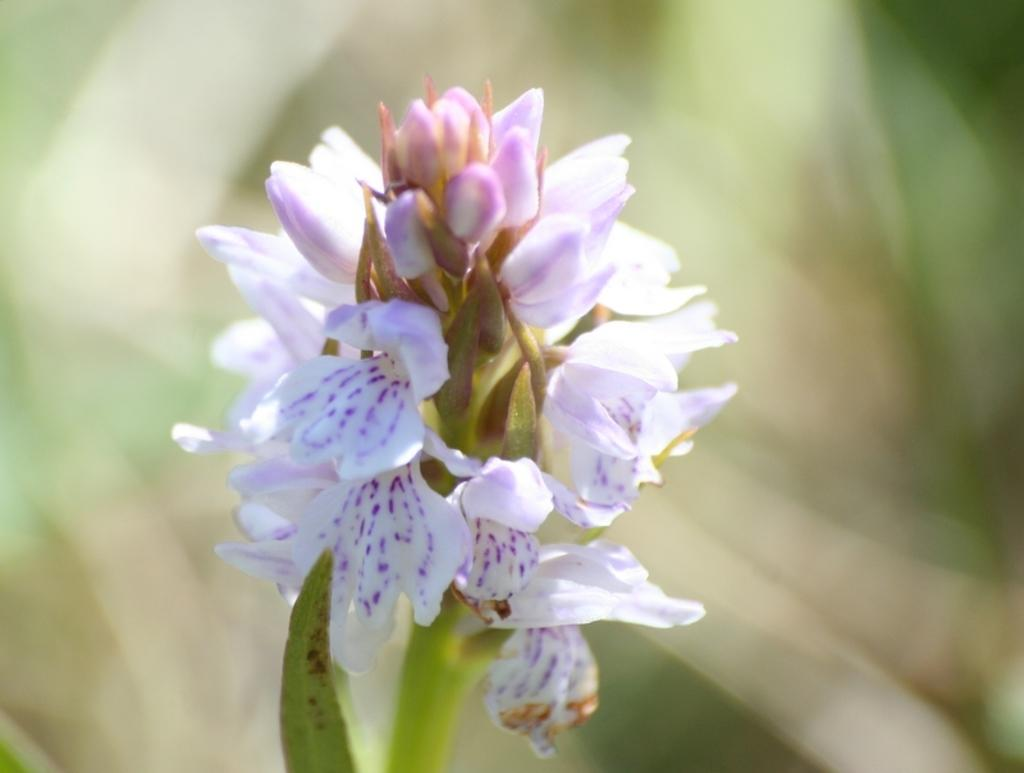Where was the image taken? The image was taken outdoors. Can you describe the background of the image? The background of the image is slightly blurred. What is the main subject of the image? There is a plant in the middle of the image. What is special about the plant? The plant has a beautiful flower and a few buds. How many children are sitting on the bench next to the plant in the image? There are no children or benches present in the image; it features a plant with a beautiful flower and buds. 